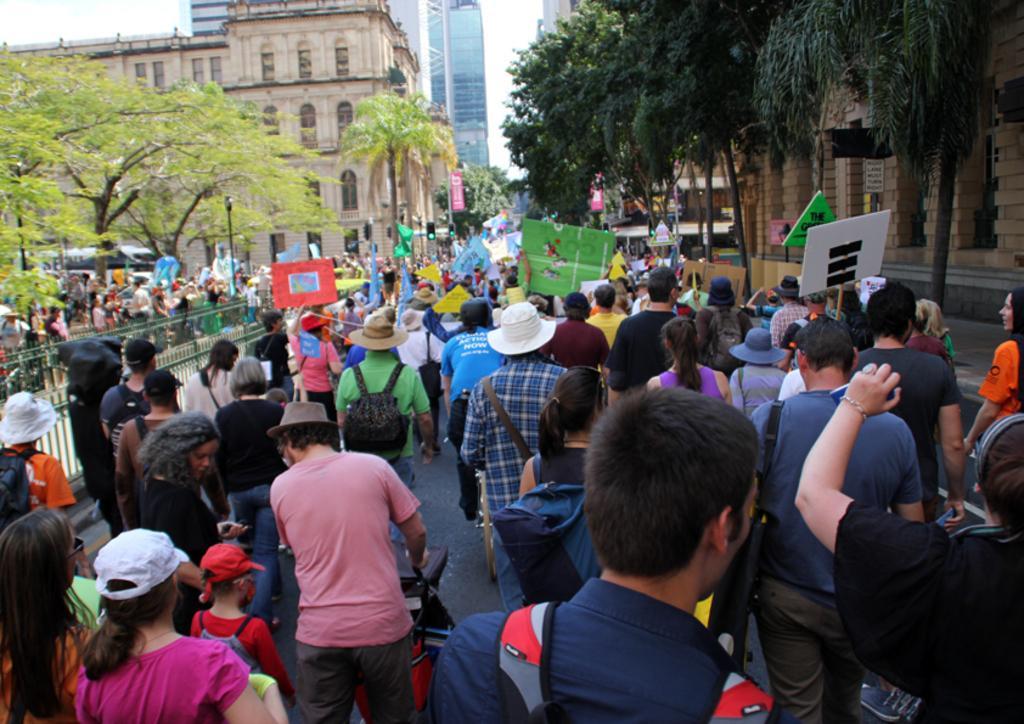How would you summarize this image in a sentence or two? In this image I can see so many people on roads among some people holding boards in their hands, on the right and left sides of the image I can see some trees and buildings. 